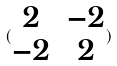<formula> <loc_0><loc_0><loc_500><loc_500>( \begin{matrix} 2 & - 2 \\ - 2 & 2 \end{matrix} )</formula> 